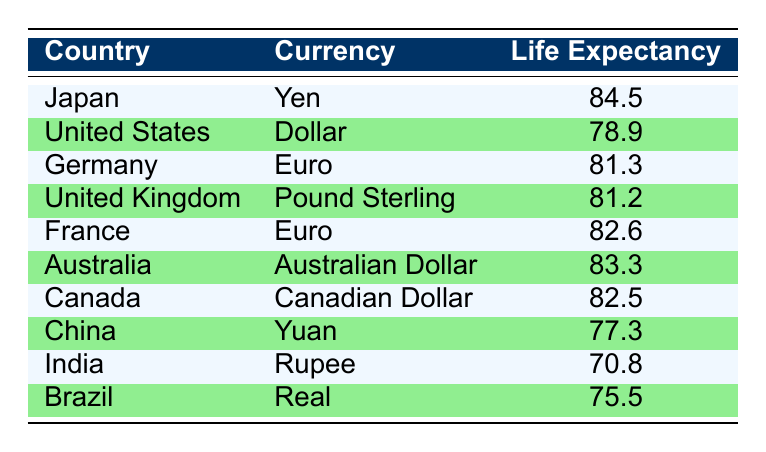What is the life expectancy in Japan? The table clearly lists Japan's life expectancy at 84.5 years.
Answer: 84.5 Which country has the lowest life expectancy? In reviewing the table, India has the lowest life expectancy at 70.8 years.
Answer: India What is the difference in life expectancy between Australia and the United States? Australia has a life expectancy of 83.3 years, while the United States has 78.9 years. The difference is 83.3 - 78.9 = 4.4 years.
Answer: 4.4 Is the life expectancy in China greater than that in Brazil? China's life expectancy is 77.3 years, and Brazil's is 75.5 years. Since 77.3 is greater than 75.5, the statement is true.
Answer: Yes What is the average life expectancy of countries using Euro as currency? Germany has a life expectancy of 81.3 years, and France has 82.6 years. To find the average, we add them: 81.3 + 82.6 = 163.9 and then divide by 2, resulting in 163.9 / 2 = 81.95.
Answer: 81.95 What is the life expectancy of all countries except for Japan and the United States? Excluding Japan (84.5) and the United States (78.9), we will sum the life expectancies of Germany (81.3), United Kingdom (81.2), France (82.6), Australia (83.3), Canada (82.5), China (77.3), India (70.8), and Brazil (75.5). The total is 81.3 + 81.2 + 82.6 + 83.3 + 82.5 + 77.3 + 70.8 + 75.5 = 635.5. There are 8 countries, so the average is 635.5 / 8 = 79.4375.
Answer: 79.44 Which currency corresponds to the country with the highest life expectancy? Japan has the highest life expectancy at 84.5 years, and its currency is Yen.
Answer: Yen Do any of the countries with life expectancy above 80 years use the Dollar as currency? The countries with life expectancy above 80 years are Japan, Germany, United Kingdom, France, Australia, and Canada. None of these use the Dollar; only the United States, which has a life expectancy of 78.9 years, uses the Dollar. Thus, the statement is false.
Answer: No 